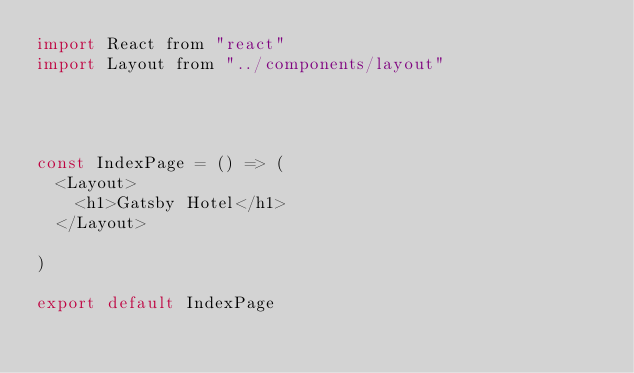Convert code to text. <code><loc_0><loc_0><loc_500><loc_500><_JavaScript_>import React from "react"
import Layout from "../components/layout"




const IndexPage = () => (
  <Layout>
    <h1>Gatsby Hotel</h1>
  </Layout>

)

export default IndexPage
</code> 